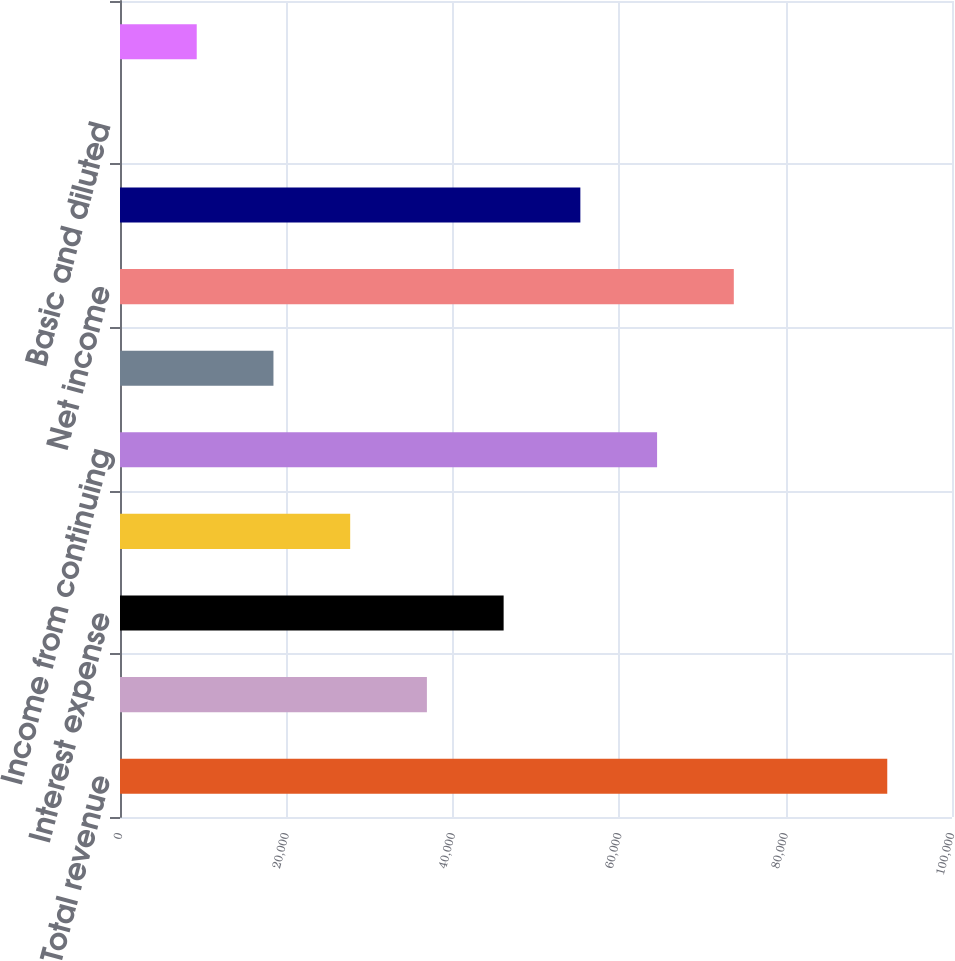Convert chart. <chart><loc_0><loc_0><loc_500><loc_500><bar_chart><fcel>Total revenue<fcel>Depreciation and amortization<fcel>Interest expense<fcel>Other expenses<fcel>Income from continuing<fcel>Income from discontinued<fcel>Net income<fcel>Net income available to common<fcel>Basic and diluted<fcel>Dividends paid per common<nl><fcel>92219<fcel>36887.8<fcel>46109.6<fcel>27665.9<fcel>64553.4<fcel>18444<fcel>73775.2<fcel>55331.5<fcel>0.28<fcel>9222.15<nl></chart> 